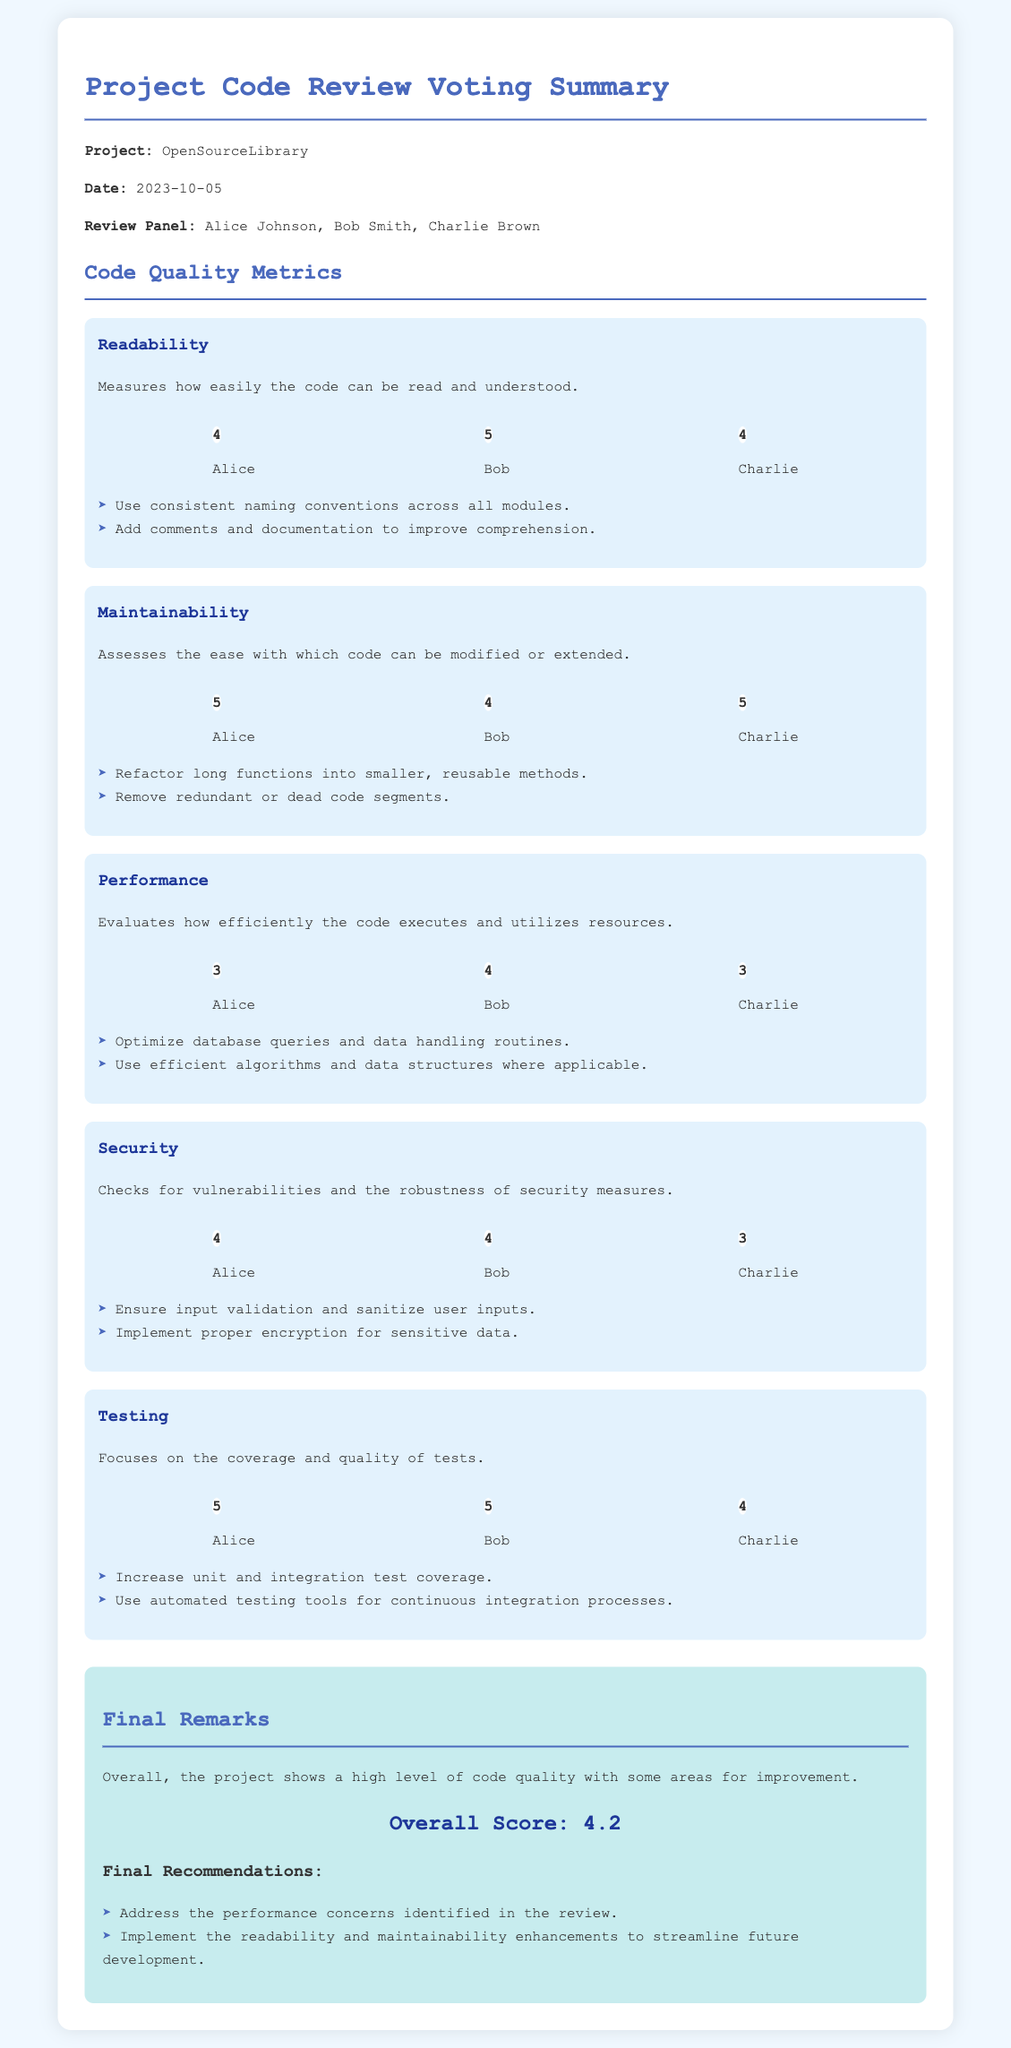What is the project name? The project name is stated clearly in the document header under "Project:".
Answer: OpenSourceLibrary What date was the code review conducted? The date of the review is mentioned right after the project name.
Answer: 2023-10-05 Who are the members of the review panel? The members of the review panel are provided in a list format under "Review Panel:".
Answer: Alice Johnson, Bob Smith, Charlie Brown What score did Bob give for Performance? Bob's score for Performance can be found in the specific section under that metric.
Answer: 4 What is the overall score for the project? The overall score is stated in the "Final Remarks" section of the document.
Answer: 4.2 What was one recommendation to improve readability? Recommendations are listed under each metric, specifically for "Readability".
Answer: Add comments and documentation to improve comprehension What metric did Alice score the highest? The scores for each reviewer are given for various metrics; this one is for Alice.
Answer: Maintainability How many scores did Charlie give for a score of 3? The document presents scores given by Charlie for different metrics, counting those that are 3.
Answer: 2 